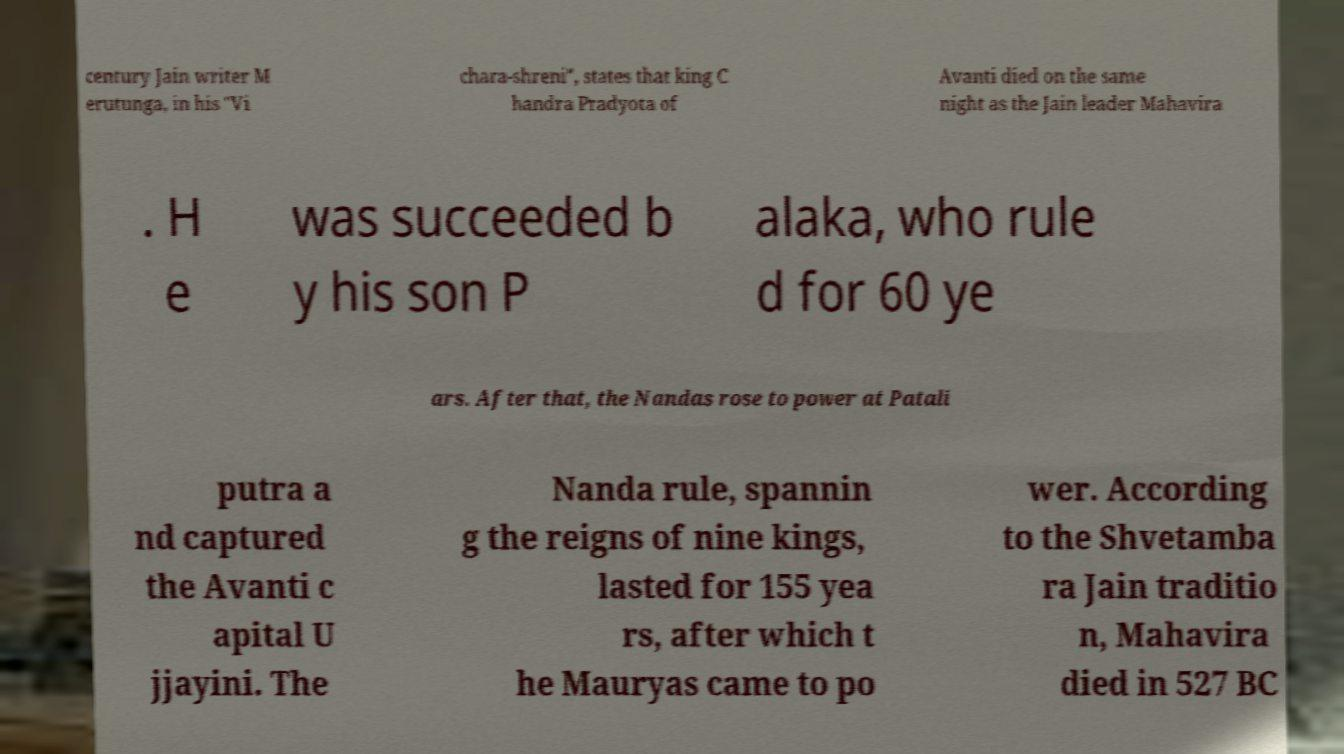Can you accurately transcribe the text from the provided image for me? century Jain writer M erutunga, in his "Vi chara-shreni", states that king C handra Pradyota of Avanti died on the same night as the Jain leader Mahavira . H e was succeeded b y his son P alaka, who rule d for 60 ye ars. After that, the Nandas rose to power at Patali putra a nd captured the Avanti c apital U jjayini. The Nanda rule, spannin g the reigns of nine kings, lasted for 155 yea rs, after which t he Mauryas came to po wer. According to the Shvetamba ra Jain traditio n, Mahavira died in 527 BC 